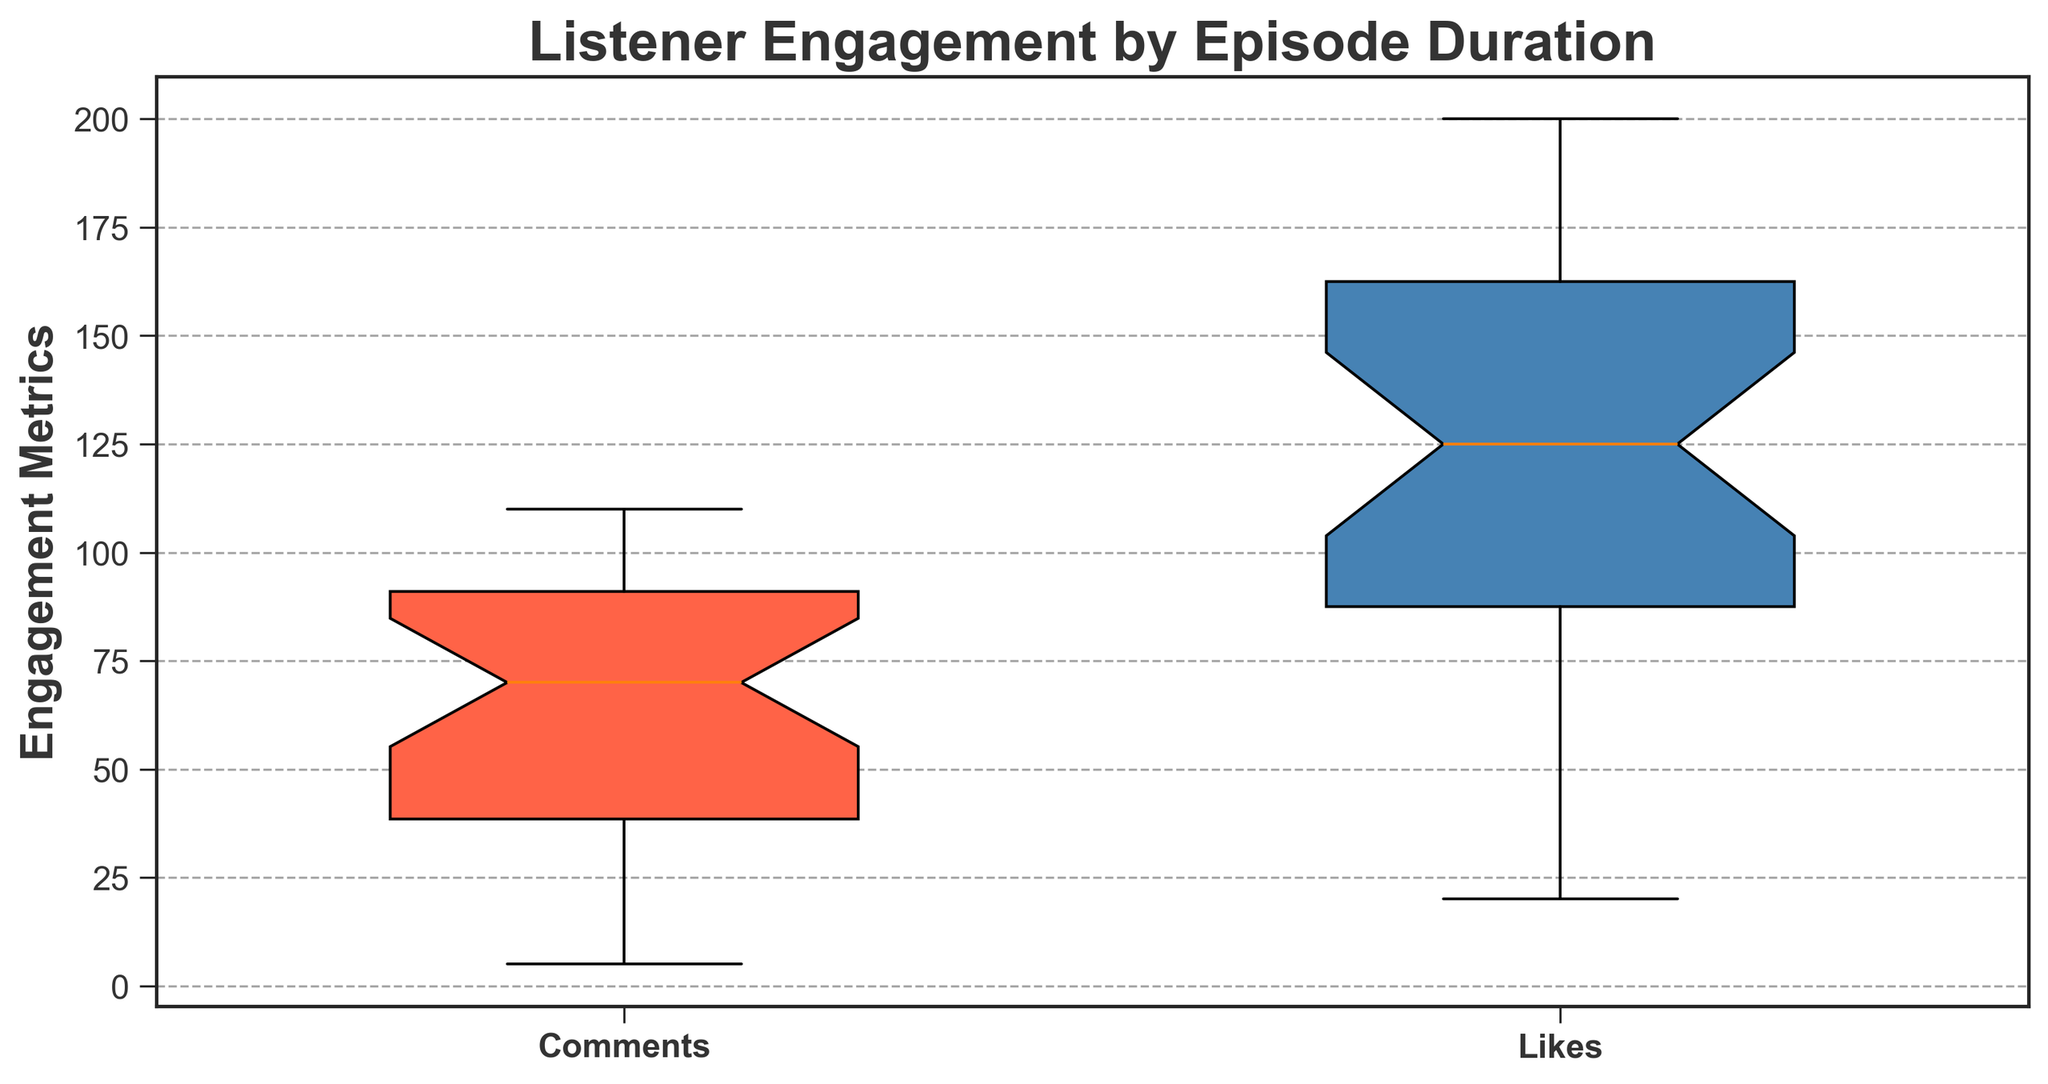What is the median number of comments? The median value can be found by identifying the middle value in the sorted list. For the 'Comments' data, the median is the value at the center.
Answer: 75 What is the interquartile range (IQR) for likes? The IQR is calculated by subtracting the first quartile (Q1) from the third quartile (Q3). From the box plot, identify Q1 and Q3 and perform the subtraction operation.
Answer: 50 Are there any outliers in the number of comments? Outliers in a box plot are typically indicated by points that lie outside the whiskers. Check if there are any dots outside the whiskers for the 'Comments' section.
Answer: No Compare the median number of likes to the median number of comments. Which is higher? Referring to the medians shown in the box plot for 'Comments' and 'Likes', compare the two values.
Answer: Likes Is the variability (spread) higher for comments or likes? Variability can be inferred from the length of the box (quartiles) and whiskers. Compare the lengths for 'Comments' and 'Likes'.
Answer: Likes What color represents the likes in the box plot? Identify the color used for the 'Likes' box in the box plot.
Answer: Blue Which has a higher maximum value, comments or likes? The maximum value is indicated by the end of the upper whisker or any outlier points. Compare the two values for 'Comments' and 'Likes'.
Answer: Likes Calculate the range of comments. The range is the difference between the maximum and minimum values. Identify these values from the whiskers for 'Comments' and perform the subtraction.
Answer: 105 Does the plot use notched or standard boxes, and what is the significance of this? Observe the shape of the boxes in the plot. Notched boxes are used to indicate the confidence interval of the median.
Answer: Notched, indicates confidence interval Compare the whisker lengths for comments and likes. What can this tell you about the data distribution? Longer whiskers can imply more variability and potential outliers. Compare the lengths of whiskers for 'Comments' and 'Likes' to infer about their distributions.
Answer: Likes have longer whiskers, implying more variability 